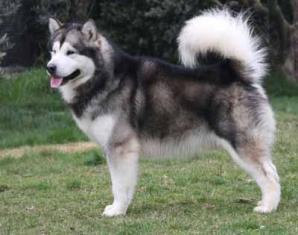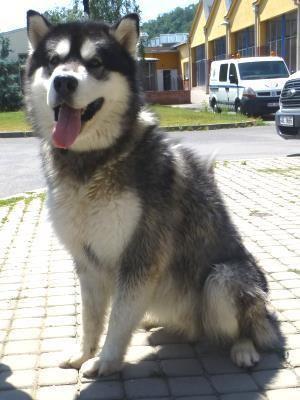The first image is the image on the left, the second image is the image on the right. Assess this claim about the two images: "Each image contains one dog, each dog has its tongue hanging down, one dog is sitting upright, and one dog is standing.". Correct or not? Answer yes or no. Yes. The first image is the image on the left, the second image is the image on the right. Assess this claim about the two images: "Both dogs have their tongues hanging out.". Correct or not? Answer yes or no. Yes. 